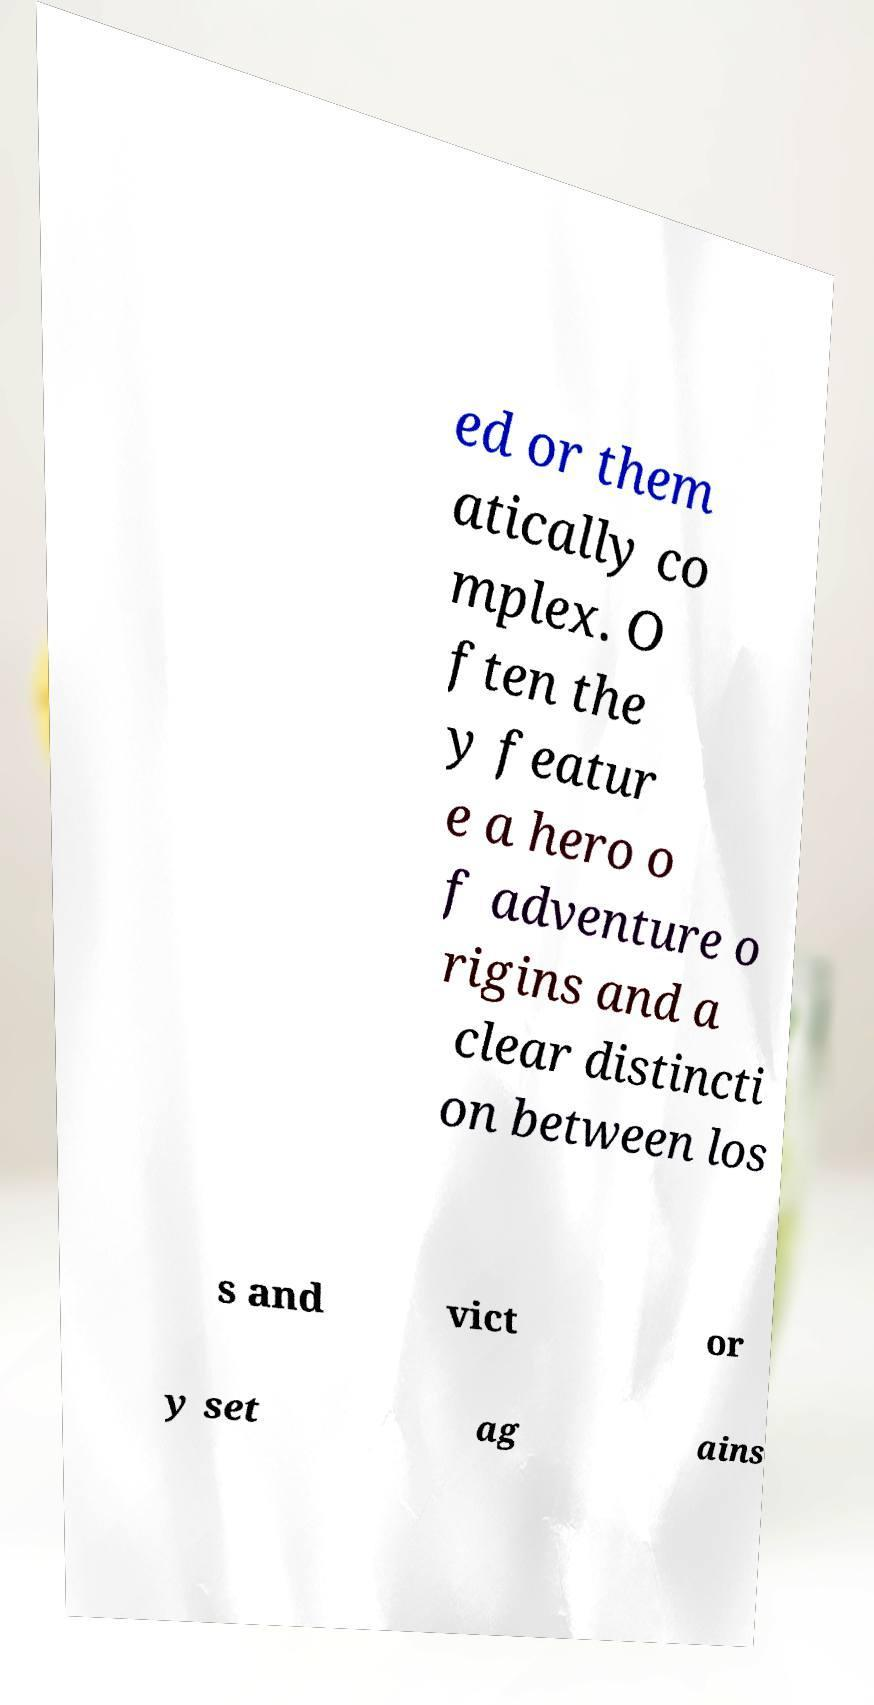Please identify and transcribe the text found in this image. ed or them atically co mplex. O ften the y featur e a hero o f adventure o rigins and a clear distincti on between los s and vict or y set ag ains 